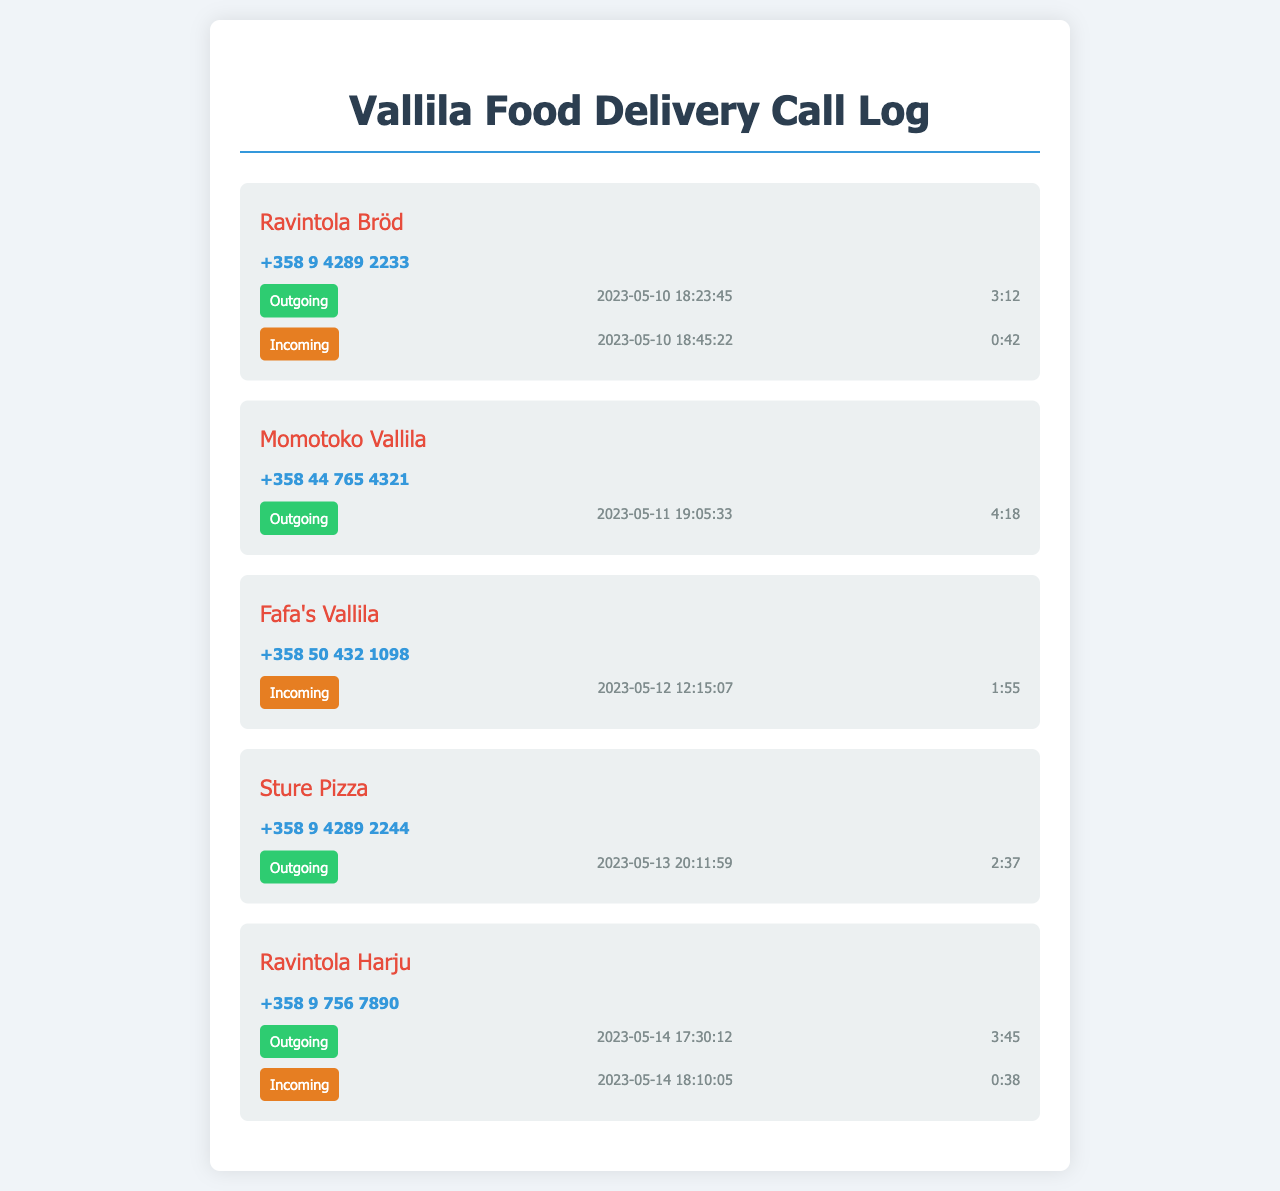What is the phone number of Ravintola Bröd? The phone number for Ravintola Bröd is listed in the call log section under their name.
Answer: +358 9 4289 2233 When did the last outgoing call to Momotoko Vallila occur? The last outgoing call made to Momotoko Vallila is recorded with a timestamp in the call log.
Answer: 2023-05-11 19:05:33 How long was the incoming call from Fafa's Vallila? The duration of the incoming call from Fafa's Vallila is mentioned in the call details section for that restaurant.
Answer: 1:55 Which restaurant had both an outgoing and an incoming call on the same day? The document shows details for multiple calls, indicating which restaurant had both types of calls on the same date.
Answer: Ravintola Harju What is the total number of restaurants listed in the document? Counting each unique restaurant entry will provide the total number of different restaurants in the call log.
Answer: 5 